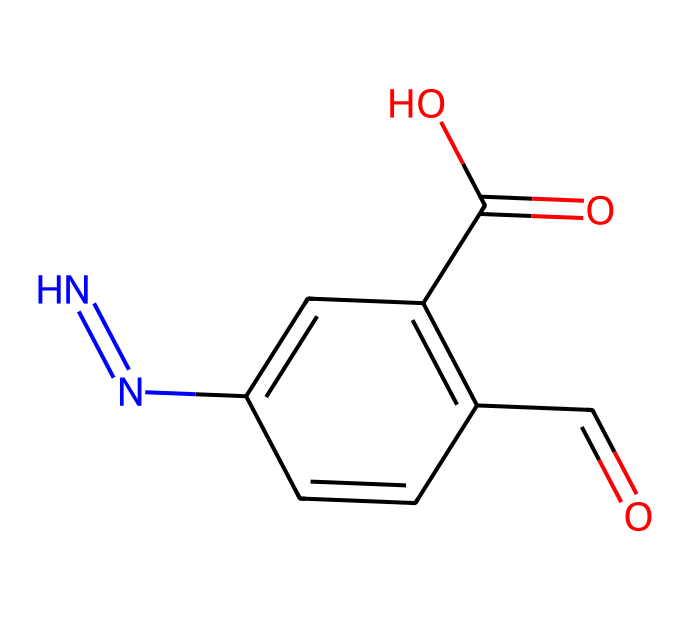What is the core structure of this photosensitive drug? The core structure consist of a benzene ring with additional functional groups. The central features include the carbonyl (C=O), carboxylic acid (C(=O)O), and azole functional groups.
Answer: benzene ring How many nitrogen atoms are present in the compound? By analyzing the SMILES representation, the nitrogen (N) is counted directly; there is one nitrogen atom indicated in the structure.
Answer: one What functional groups are present in this drug? The SMILES indicates multiple functional groups, including a carbonyl, a carboxylic acid, and an azole. By evaluating the components in the structure, these groups can be identified.
Answer: carbonyl, carboxylic acid, azo What type of reaction is this molecule likely to undergo when exposed to light? Given the concept of photosensitive drugs, this compound is designed for light-responsive therapies, which often involves photochemical reactions that can change or activate the drug upon exposure to specific wavelengths of light.
Answer: photochemical reaction What is the potential therapeutic application of this drug? Since it is designed as a photosensitive drug, it indicates potential use in targeted therapy, particularly in conditions like cancer treatment where localized activation is beneficial.
Answer: targeted therapy 